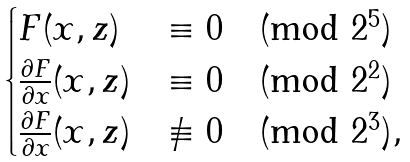<formula> <loc_0><loc_0><loc_500><loc_500>\begin{cases} F ( x , z ) & \equiv 0 \pmod { 2 ^ { 5 } } \\ \frac { \partial { F } } { \partial { x } } ( x , z ) & \equiv 0 \pmod { 2 ^ { 2 } } \\ \frac { \partial { F } } { \partial { x } } ( x , z ) & \not \equiv 0 \pmod { 2 ^ { 3 } } , \end{cases}</formula> 